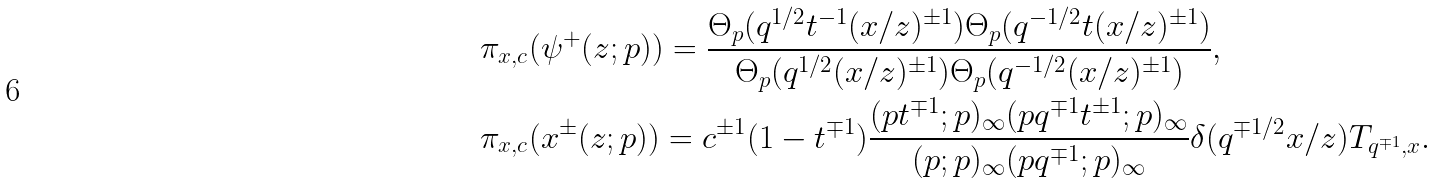Convert formula to latex. <formula><loc_0><loc_0><loc_500><loc_500>& \pi _ { x , c } ( \psi ^ { + } ( z ; p ) ) = \frac { \Theta _ { p } ( q ^ { 1 / 2 } t ^ { - 1 } ( x / z ) ^ { \pm 1 } ) \Theta _ { p } ( q ^ { - 1 / 2 } t ( x / z ) ^ { \pm 1 } ) } { \Theta _ { p } ( q ^ { 1 / 2 } ( x / z ) ^ { \pm 1 } ) \Theta _ { p } ( q ^ { - 1 / 2 } ( x / z ) ^ { \pm 1 } ) } , \\ & \pi _ { x , c } ( x ^ { \pm } ( z ; p ) ) = c ^ { \pm 1 } ( 1 - t ^ { \mp 1 } ) \frac { ( p t ^ { \mp 1 } ; p ) _ { \infty } ( p q ^ { \mp 1 } t ^ { \pm 1 } ; p ) _ { \infty } } { ( p ; p ) _ { \infty } ( p q ^ { \mp 1 } ; p ) _ { \infty } } \delta ( q ^ { \mp 1 / 2 } x / z ) T _ { q ^ { \mp 1 } , x } .</formula> 